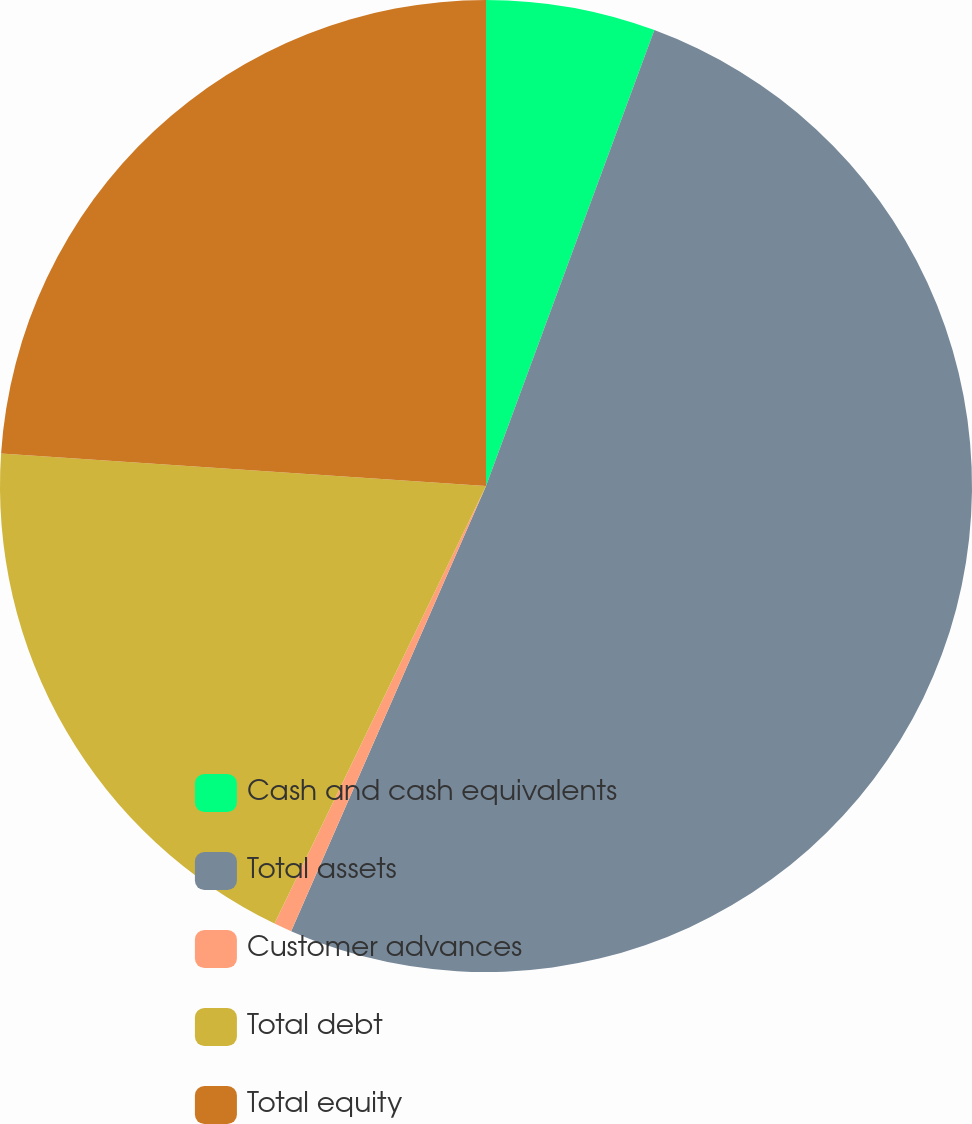Convert chart to OTSL. <chart><loc_0><loc_0><loc_500><loc_500><pie_chart><fcel>Cash and cash equivalents<fcel>Total assets<fcel>Customer advances<fcel>Total debt<fcel>Total equity<nl><fcel>5.63%<fcel>50.93%<fcel>0.6%<fcel>18.9%<fcel>23.93%<nl></chart> 